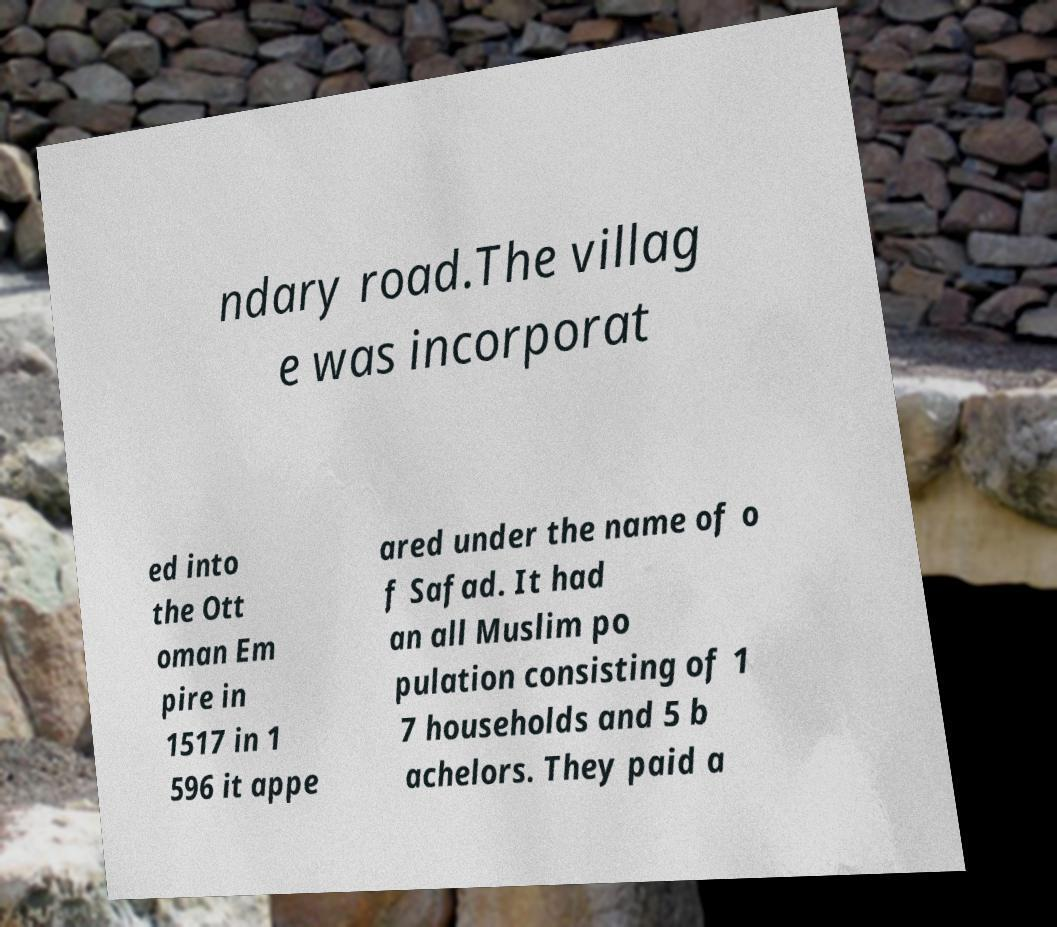Could you extract and type out the text from this image? ndary road.The villag e was incorporat ed into the Ott oman Em pire in 1517 in 1 596 it appe ared under the name of o f Safad. It had an all Muslim po pulation consisting of 1 7 households and 5 b achelors. They paid a 